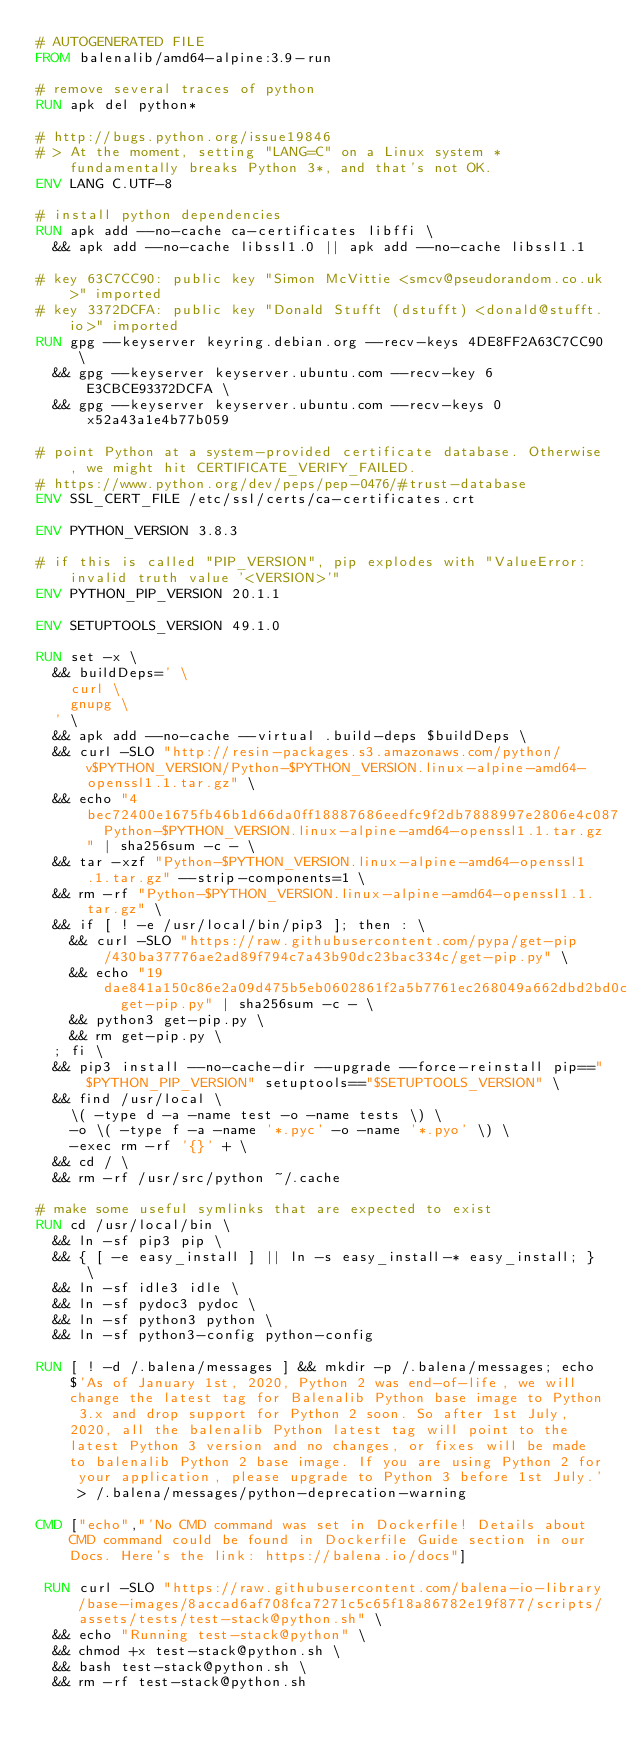Convert code to text. <code><loc_0><loc_0><loc_500><loc_500><_Dockerfile_># AUTOGENERATED FILE
FROM balenalib/amd64-alpine:3.9-run

# remove several traces of python
RUN apk del python*

# http://bugs.python.org/issue19846
# > At the moment, setting "LANG=C" on a Linux system *fundamentally breaks Python 3*, and that's not OK.
ENV LANG C.UTF-8

# install python dependencies
RUN apk add --no-cache ca-certificates libffi \
	&& apk add --no-cache libssl1.0 || apk add --no-cache libssl1.1

# key 63C7CC90: public key "Simon McVittie <smcv@pseudorandom.co.uk>" imported
# key 3372DCFA: public key "Donald Stufft (dstufft) <donald@stufft.io>" imported
RUN gpg --keyserver keyring.debian.org --recv-keys 4DE8FF2A63C7CC90 \
	&& gpg --keyserver keyserver.ubuntu.com --recv-key 6E3CBCE93372DCFA \
	&& gpg --keyserver keyserver.ubuntu.com --recv-keys 0x52a43a1e4b77b059

# point Python at a system-provided certificate database. Otherwise, we might hit CERTIFICATE_VERIFY_FAILED.
# https://www.python.org/dev/peps/pep-0476/#trust-database
ENV SSL_CERT_FILE /etc/ssl/certs/ca-certificates.crt

ENV PYTHON_VERSION 3.8.3

# if this is called "PIP_VERSION", pip explodes with "ValueError: invalid truth value '<VERSION>'"
ENV PYTHON_PIP_VERSION 20.1.1

ENV SETUPTOOLS_VERSION 49.1.0

RUN set -x \
	&& buildDeps=' \
		curl \
		gnupg \
	' \
	&& apk add --no-cache --virtual .build-deps $buildDeps \
	&& curl -SLO "http://resin-packages.s3.amazonaws.com/python/v$PYTHON_VERSION/Python-$PYTHON_VERSION.linux-alpine-amd64-openssl1.1.tar.gz" \
	&& echo "4bec72400e1675fb46b1d66da0ff18887686eedfc9f2db7888997e2806e4c087  Python-$PYTHON_VERSION.linux-alpine-amd64-openssl1.1.tar.gz" | sha256sum -c - \
	&& tar -xzf "Python-$PYTHON_VERSION.linux-alpine-amd64-openssl1.1.tar.gz" --strip-components=1 \
	&& rm -rf "Python-$PYTHON_VERSION.linux-alpine-amd64-openssl1.1.tar.gz" \
	&& if [ ! -e /usr/local/bin/pip3 ]; then : \
		&& curl -SLO "https://raw.githubusercontent.com/pypa/get-pip/430ba37776ae2ad89f794c7a43b90dc23bac334c/get-pip.py" \
		&& echo "19dae841a150c86e2a09d475b5eb0602861f2a5b7761ec268049a662dbd2bd0c  get-pip.py" | sha256sum -c - \
		&& python3 get-pip.py \
		&& rm get-pip.py \
	; fi \
	&& pip3 install --no-cache-dir --upgrade --force-reinstall pip=="$PYTHON_PIP_VERSION" setuptools=="$SETUPTOOLS_VERSION" \
	&& find /usr/local \
		\( -type d -a -name test -o -name tests \) \
		-o \( -type f -a -name '*.pyc' -o -name '*.pyo' \) \
		-exec rm -rf '{}' + \
	&& cd / \
	&& rm -rf /usr/src/python ~/.cache

# make some useful symlinks that are expected to exist
RUN cd /usr/local/bin \
	&& ln -sf pip3 pip \
	&& { [ -e easy_install ] || ln -s easy_install-* easy_install; } \
	&& ln -sf idle3 idle \
	&& ln -sf pydoc3 pydoc \
	&& ln -sf python3 python \
	&& ln -sf python3-config python-config

RUN [ ! -d /.balena/messages ] && mkdir -p /.balena/messages; echo $'As of January 1st, 2020, Python 2 was end-of-life, we will change the latest tag for Balenalib Python base image to Python 3.x and drop support for Python 2 soon. So after 1st July, 2020, all the balenalib Python latest tag will point to the latest Python 3 version and no changes, or fixes will be made to balenalib Python 2 base image. If you are using Python 2 for your application, please upgrade to Python 3 before 1st July.' > /.balena/messages/python-deprecation-warning

CMD ["echo","'No CMD command was set in Dockerfile! Details about CMD command could be found in Dockerfile Guide section in our Docs. Here's the link: https://balena.io/docs"]

 RUN curl -SLO "https://raw.githubusercontent.com/balena-io-library/base-images/8accad6af708fca7271c5c65f18a86782e19f877/scripts/assets/tests/test-stack@python.sh" \
  && echo "Running test-stack@python" \
  && chmod +x test-stack@python.sh \
  && bash test-stack@python.sh \
  && rm -rf test-stack@python.sh 
</code> 